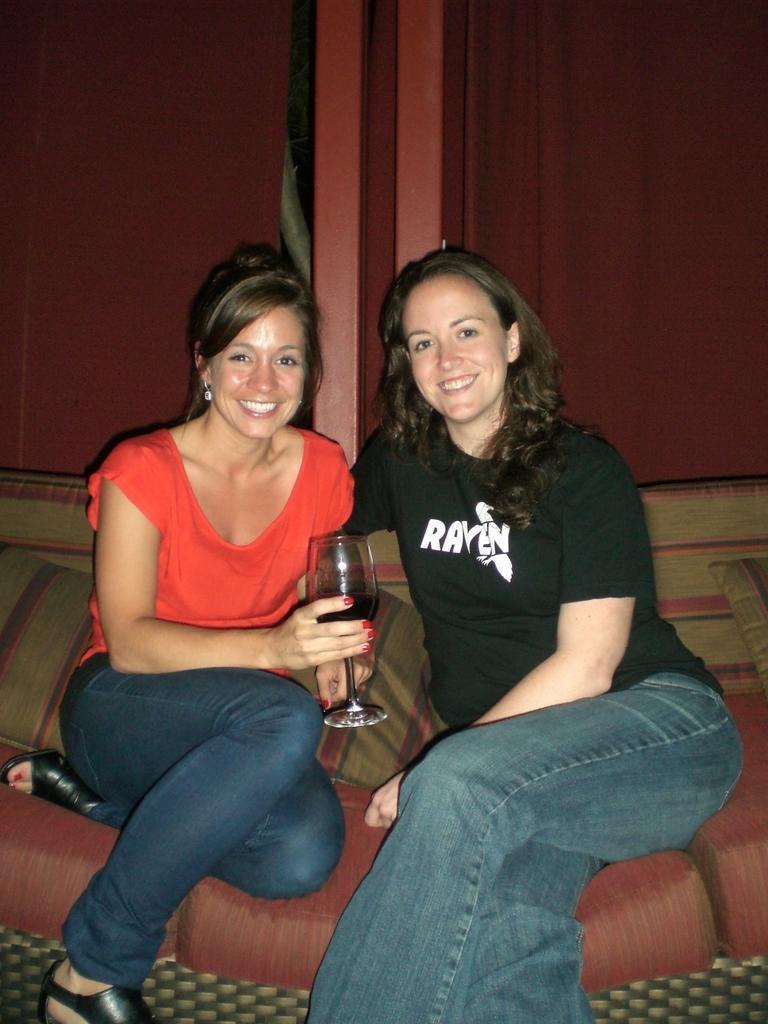Describe this image in one or two sentences. In this picture,there are two women sitting on a couch. One is in orange top with a denim pant holding a wine glass in her hand. The other is in a black T shirt and a denim pant. Both are smiling at the camera. There are two pillows beside them. There are cupboards behind them. 